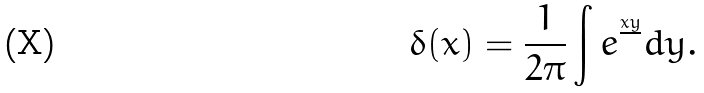Convert formula to latex. <formula><loc_0><loc_0><loc_500><loc_500>\delta ( x ) = \frac { 1 } { 2 \pi } \int e ^ { \frac { x y } { } } d y .</formula> 